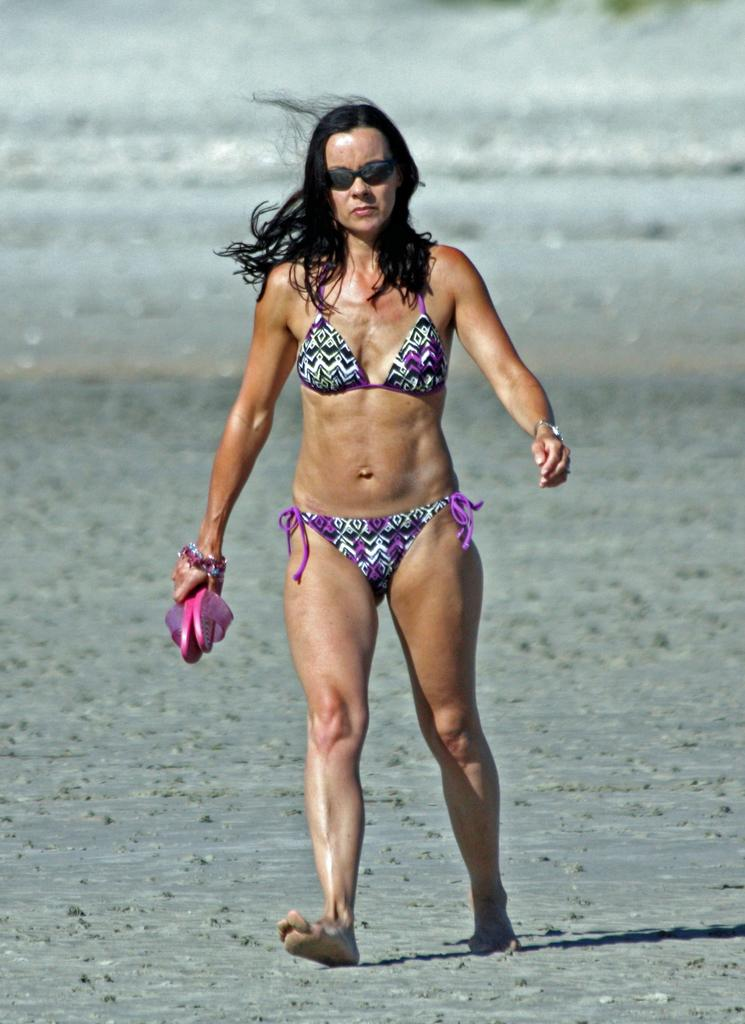What is happening in the image? There is a person in the image, and they are walking on the ground. What is the person holding in the image? The person is holding a footwear. What type of nose can be seen on the quince in the image? There is no quince or nose present in the image; it features a person walking and holding a footwear. 